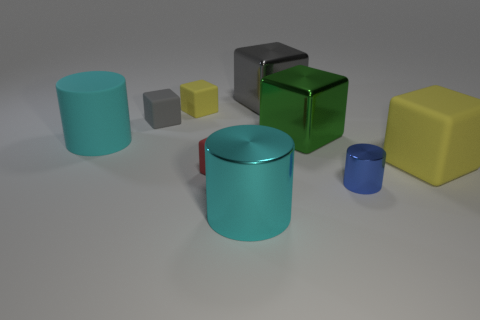What number of yellow things are made of the same material as the tiny blue object?
Your response must be concise. 0. Is the blue object made of the same material as the cyan cylinder behind the large matte cube?
Provide a short and direct response. No. What number of things are green shiny blocks that are behind the cyan rubber object or tiny yellow metallic things?
Your answer should be compact. 1. There is a cyan object in front of the big matte object behind the yellow block that is on the right side of the gray metal cube; what is its size?
Offer a very short reply. Large. What material is the thing that is the same color as the large metal cylinder?
Provide a short and direct response. Rubber. There is a yellow cube that is right of the yellow rubber block behind the green metal cube; what size is it?
Give a very brief answer. Large. How many small objects are either red things or cyan objects?
Provide a succinct answer. 1. Is the number of big matte cylinders less than the number of purple shiny cylinders?
Provide a short and direct response. No. Is the big rubber cylinder the same color as the large shiny cylinder?
Provide a short and direct response. Yes. Is the number of blue metal things greater than the number of shiny things?
Give a very brief answer. No. 